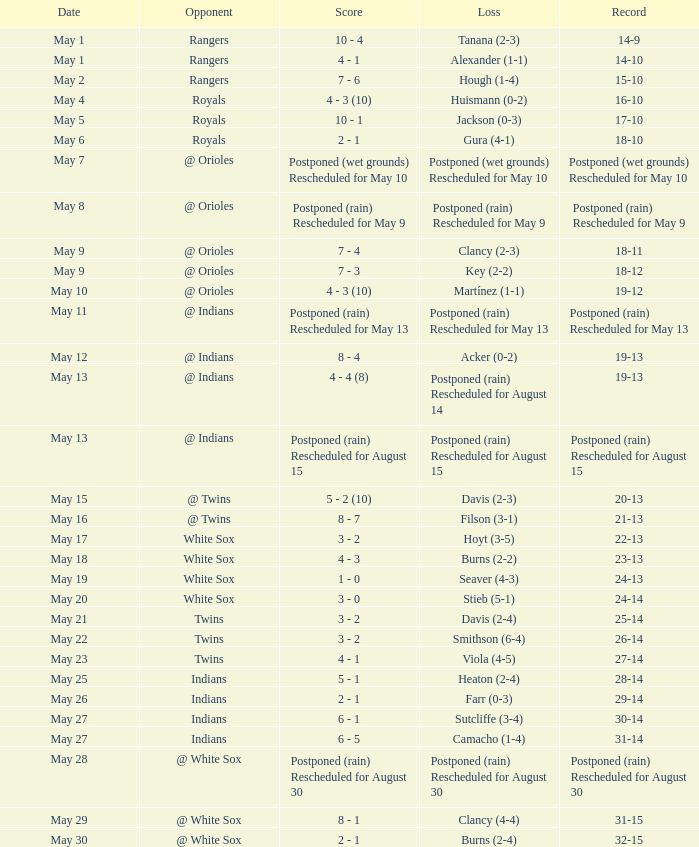What was the record at the game against the Indians with a loss of Camacho (1-4)? 31-14. 